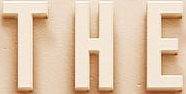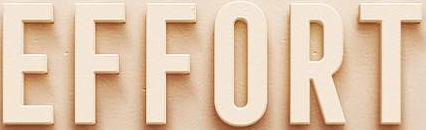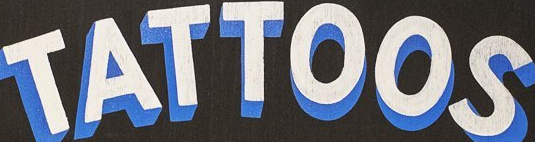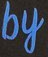Identify the words shown in these images in order, separated by a semicolon. THE; EFFORT; TATTOOS; by 